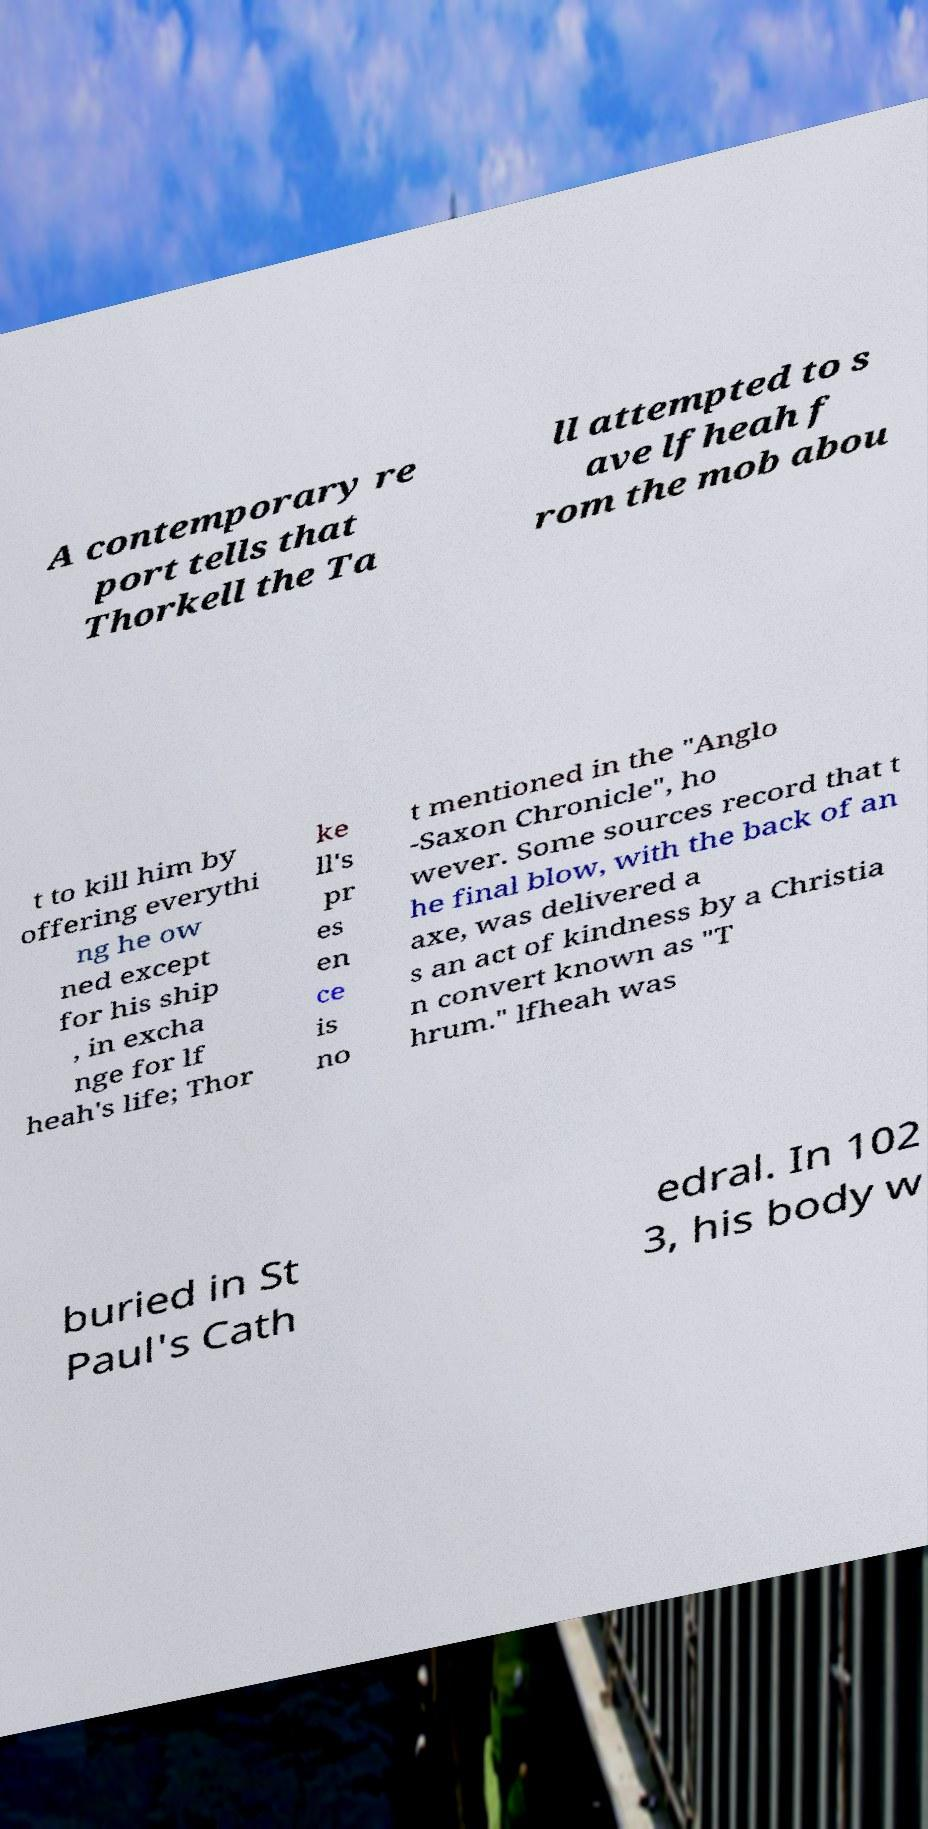There's text embedded in this image that I need extracted. Can you transcribe it verbatim? A contemporary re port tells that Thorkell the Ta ll attempted to s ave lfheah f rom the mob abou t to kill him by offering everythi ng he ow ned except for his ship , in excha nge for lf heah's life; Thor ke ll's pr es en ce is no t mentioned in the "Anglo -Saxon Chronicle", ho wever. Some sources record that t he final blow, with the back of an axe, was delivered a s an act of kindness by a Christia n convert known as "T hrum." lfheah was buried in St Paul's Cath edral. In 102 3, his body w 